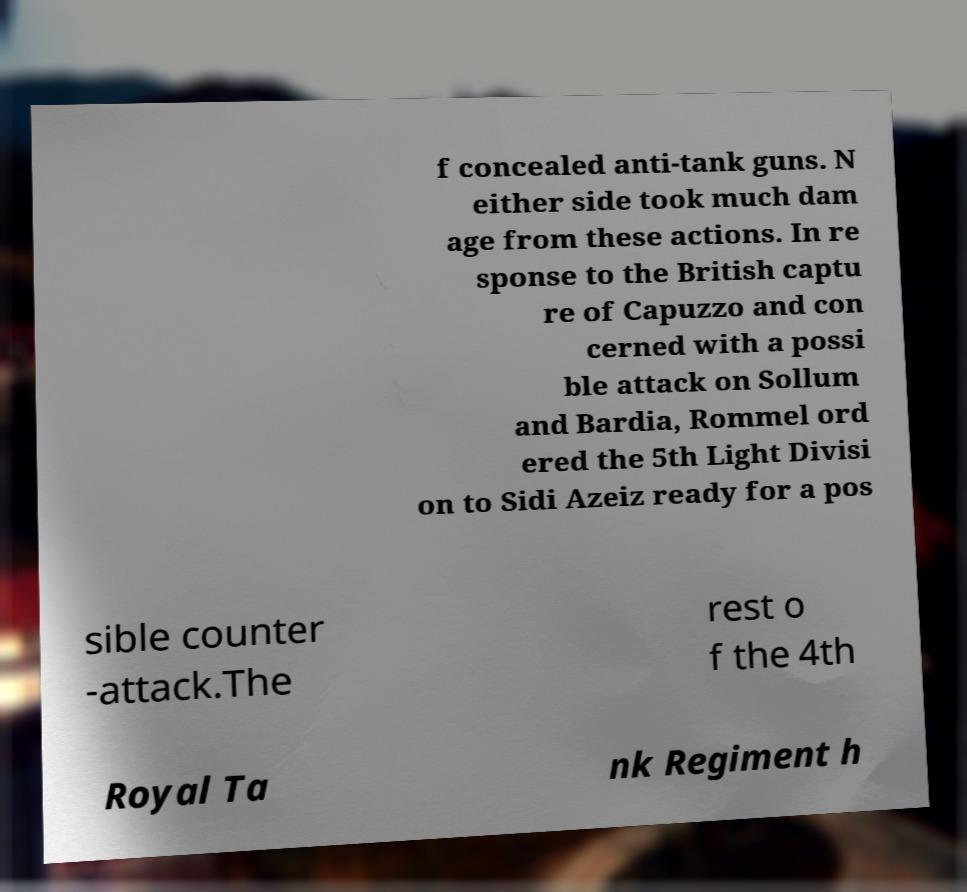Can you accurately transcribe the text from the provided image for me? f concealed anti-tank guns. N either side took much dam age from these actions. In re sponse to the British captu re of Capuzzo and con cerned with a possi ble attack on Sollum and Bardia, Rommel ord ered the 5th Light Divisi on to Sidi Azeiz ready for a pos sible counter -attack.The rest o f the 4th Royal Ta nk Regiment h 